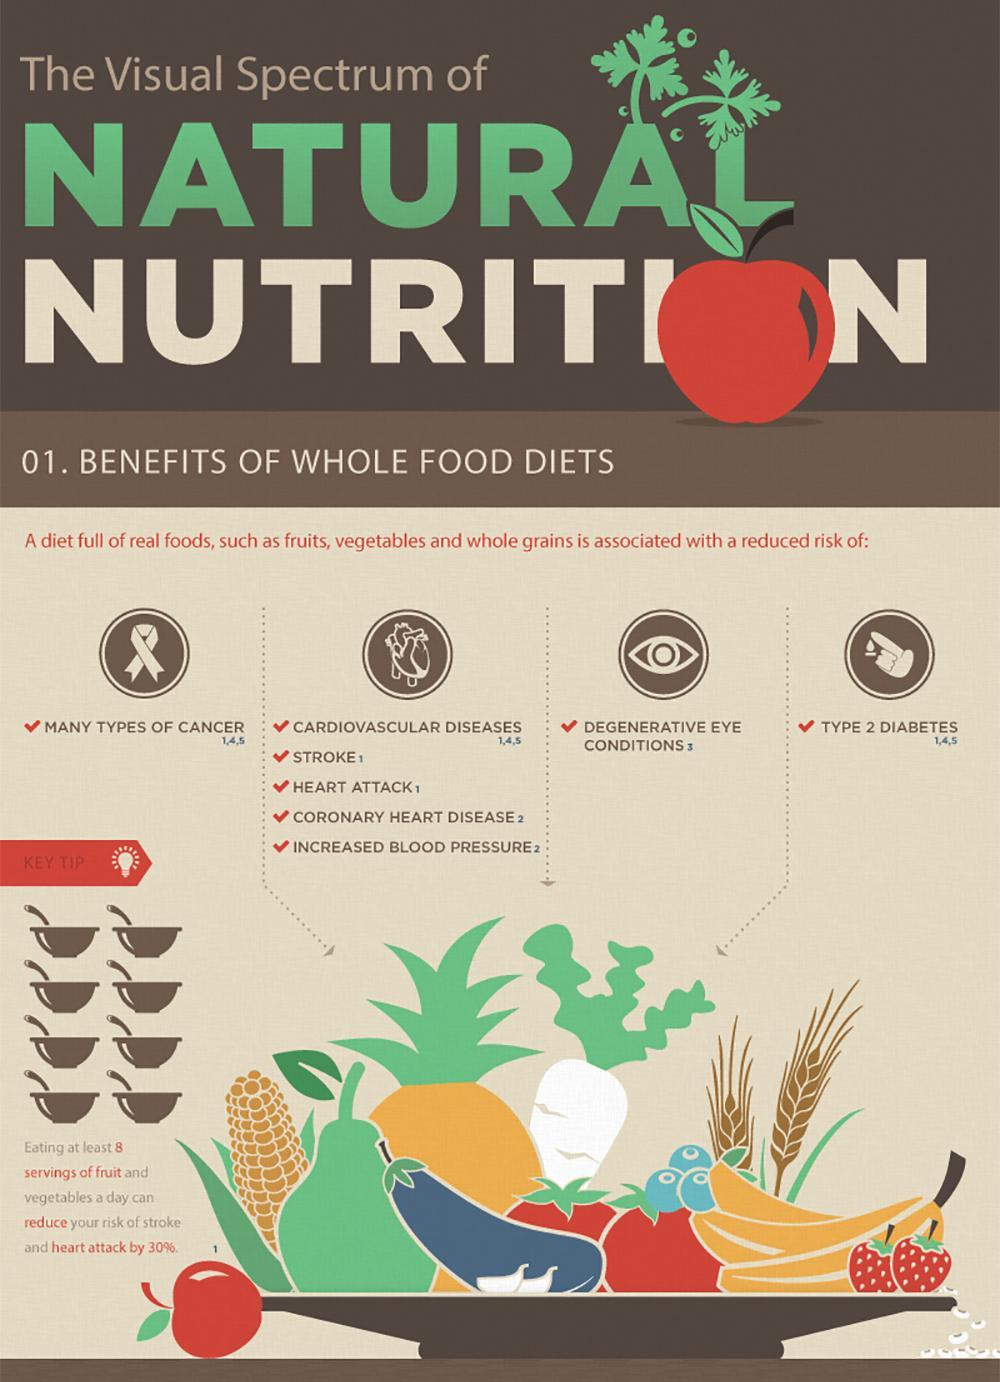How many risks are associated with the heart due to the lack of healthy diet?
Answer the question with a short phrase. 5 